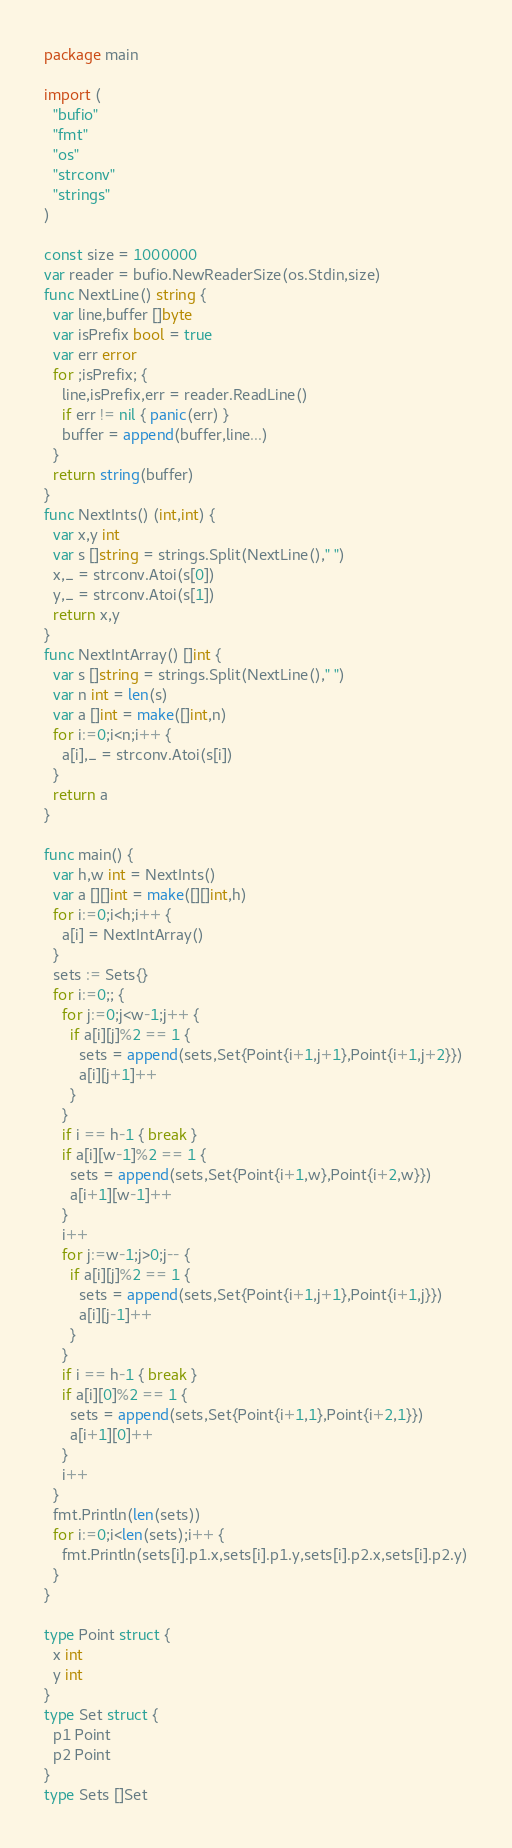Convert code to text. <code><loc_0><loc_0><loc_500><loc_500><_Go_>package main

import (
  "bufio"
  "fmt"
  "os"
  "strconv"
  "strings"
)

const size = 1000000
var reader = bufio.NewReaderSize(os.Stdin,size)
func NextLine() string {
  var line,buffer []byte
  var isPrefix bool = true
  var err error
  for ;isPrefix; {
    line,isPrefix,err = reader.ReadLine()
    if err != nil { panic(err) }
    buffer = append(buffer,line...)
  }
  return string(buffer)
}
func NextInts() (int,int) {
  var x,y int
  var s []string = strings.Split(NextLine()," ")
  x,_ = strconv.Atoi(s[0])
  y,_ = strconv.Atoi(s[1])
  return x,y
}
func NextIntArray() []int {
  var s []string = strings.Split(NextLine()," ")
  var n int = len(s)
  var a []int = make([]int,n)
  for i:=0;i<n;i++ {
    a[i],_ = strconv.Atoi(s[i])
  }
  return a
}

func main() {
  var h,w int = NextInts()
  var a [][]int = make([][]int,h)
  for i:=0;i<h;i++ {
    a[i] = NextIntArray()
  }
  sets := Sets{}
  for i:=0;; {
    for j:=0;j<w-1;j++ {
      if a[i][j]%2 == 1 {
        sets = append(sets,Set{Point{i+1,j+1},Point{i+1,j+2}})
        a[i][j+1]++
      }
    }
    if i == h-1 { break }
    if a[i][w-1]%2 == 1 {
      sets = append(sets,Set{Point{i+1,w},Point{i+2,w}})
      a[i+1][w-1]++
    }
    i++
    for j:=w-1;j>0;j-- {
      if a[i][j]%2 == 1 {
        sets = append(sets,Set{Point{i+1,j+1},Point{i+1,j}})
        a[i][j-1]++
      }
    }
    if i == h-1 { break }
    if a[i][0]%2 == 1 {
      sets = append(sets,Set{Point{i+1,1},Point{i+2,1}})
      a[i+1][0]++
    }
    i++
  }
  fmt.Println(len(sets))
  for i:=0;i<len(sets);i++ {
    fmt.Println(sets[i].p1.x,sets[i].p1.y,sets[i].p2.x,sets[i].p2.y)
  }
}

type Point struct {
  x int
  y int
}
type Set struct {
  p1 Point
  p2 Point
}
type Sets []Set</code> 